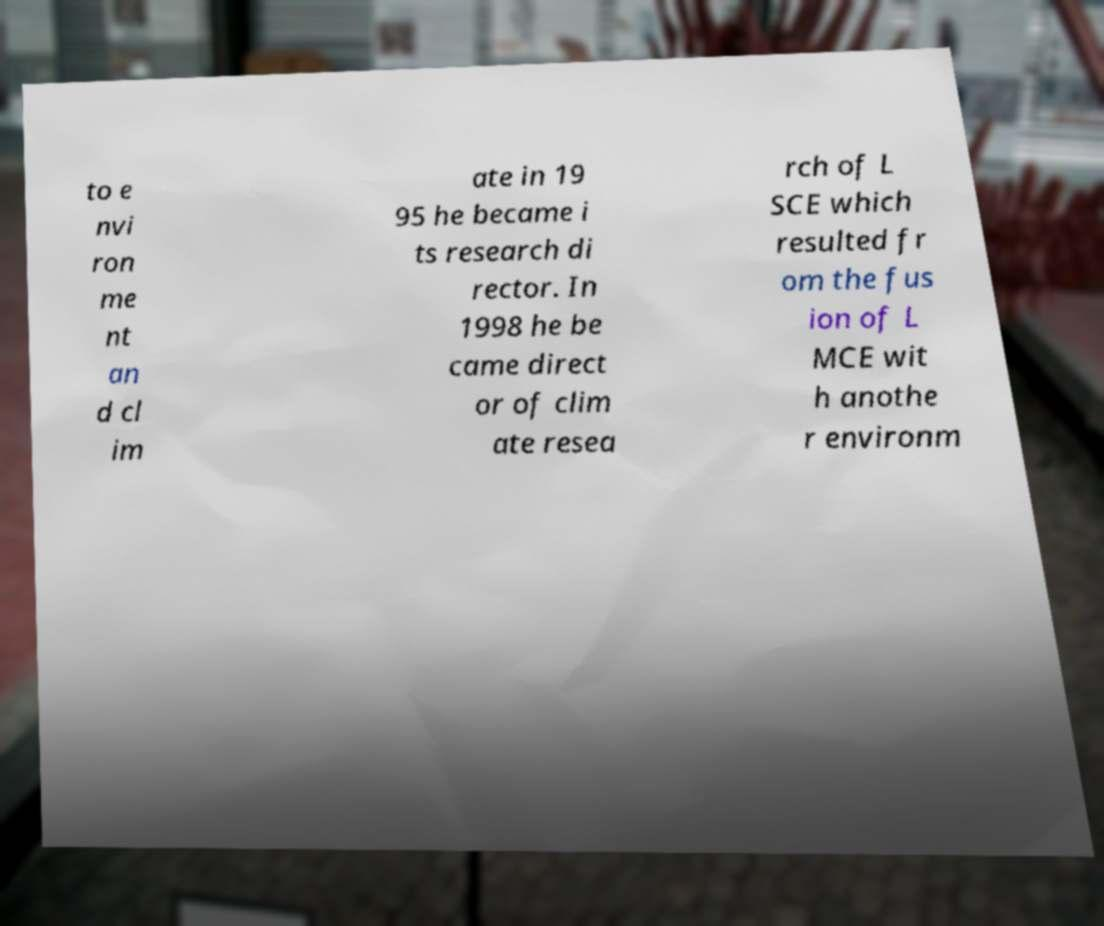Can you read and provide the text displayed in the image?This photo seems to have some interesting text. Can you extract and type it out for me? to e nvi ron me nt an d cl im ate in 19 95 he became i ts research di rector. In 1998 he be came direct or of clim ate resea rch of L SCE which resulted fr om the fus ion of L MCE wit h anothe r environm 